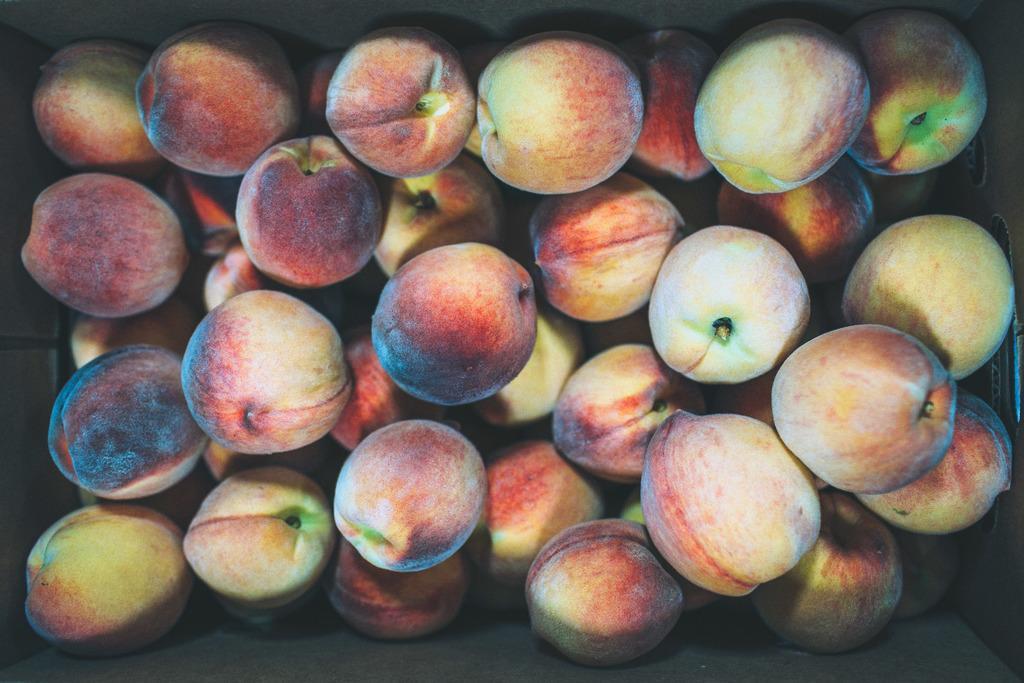Please provide a concise description of this image. This is a peach fruit. 